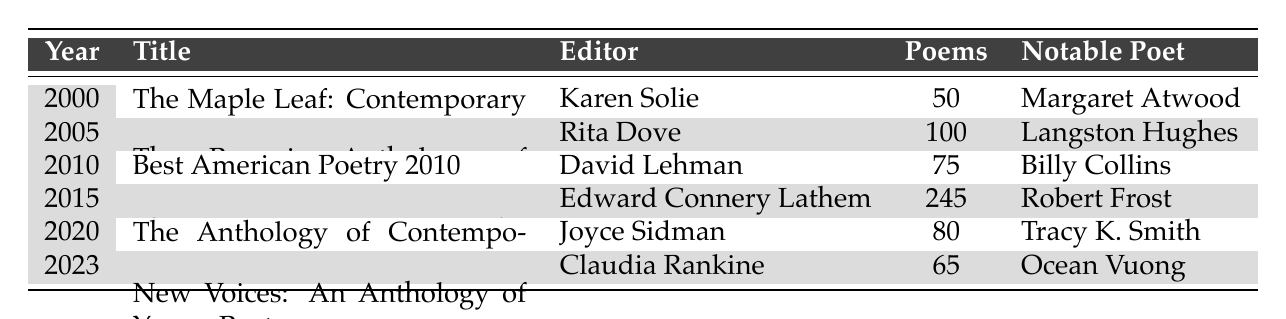What is the title of the poetry anthology published in 2015? The table lists the anthology titles along with the corresponding years. By looking at the year 2015, the title listed is "The Poetry of Robert Frost: The Collected Poems."
Answer: The Poetry of Robert Frost: The Collected Poems Who is the editor of the anthology published in 2020? To find the editor for the anthology published in 2020, locate the year 2020 in the table, which shows the editor as Joyce Sidman.
Answer: Joyce Sidman How many poems are included in "The Penguin Anthology of Twentieth-Century American Poetry"? The number of poems is listed in the table under the corresponding title. For "The Penguin Anthology of Twentieth-Century American Poetry," there are 100 poems.
Answer: 100 Which anthology features the notable poet Robert Frost? The notable poet for each anthology is provided in the table. By checking the notable poets, Robert Frost is associated with "The Poetry of Robert Frost: The Collected Poems," published in 2015.
Answer: The Poetry of Robert Frost: The Collected Poems What is the average number of poems in the anthologies listed in the table? To find the average, sum the number of poems (50 + 100 + 75 + 245 + 80 + 65 = 615) and divide by the total number of anthologies (6). Thus, 615 / 6 = 102.5.
Answer: 102.5 Is there an anthology published in 2023? By inspecting the table, there is indeed an anthology listed for the year 2023, titled "New Voices: An Anthology of Young Poets."
Answer: Yes What is the difference in the number of poems between the anthology published in 2010 and the one published in 2015? The anthology from 2010 has 75 poems, and the one from 2015 has 245 poems. The difference is calculated as 245 - 75 = 170.
Answer: 170 How many anthologies were published between 2005 and 2020? To find the number of anthologies, count the entries for the years 2005, 2010, and 2015, 2020, which are four anthologies in total.
Answer: 4 Which editor has published the most anthologies according to the table data? To determine the editor with the most publications, count the entries of each editor; each listed editor only accompanies one anthology. Hence, no editor has multiple entries.
Answer: None What are the titles of anthologies that include more than 70 poems? Assess the number of poems for each anthology in the table: "The Penguin Anthology of Twentieth-Century American Poetry" (100), "The Poetry of Robert Frost: The Collected Poems" (245), and "The Anthology of Contemporary Poetry" (80) meet the criteria.
Answer: The Penguin Anthology of Twentieth-Century American Poetry, The Poetry of Robert Frost: The Collected Poems, The Anthology of Contemporary Poetry 